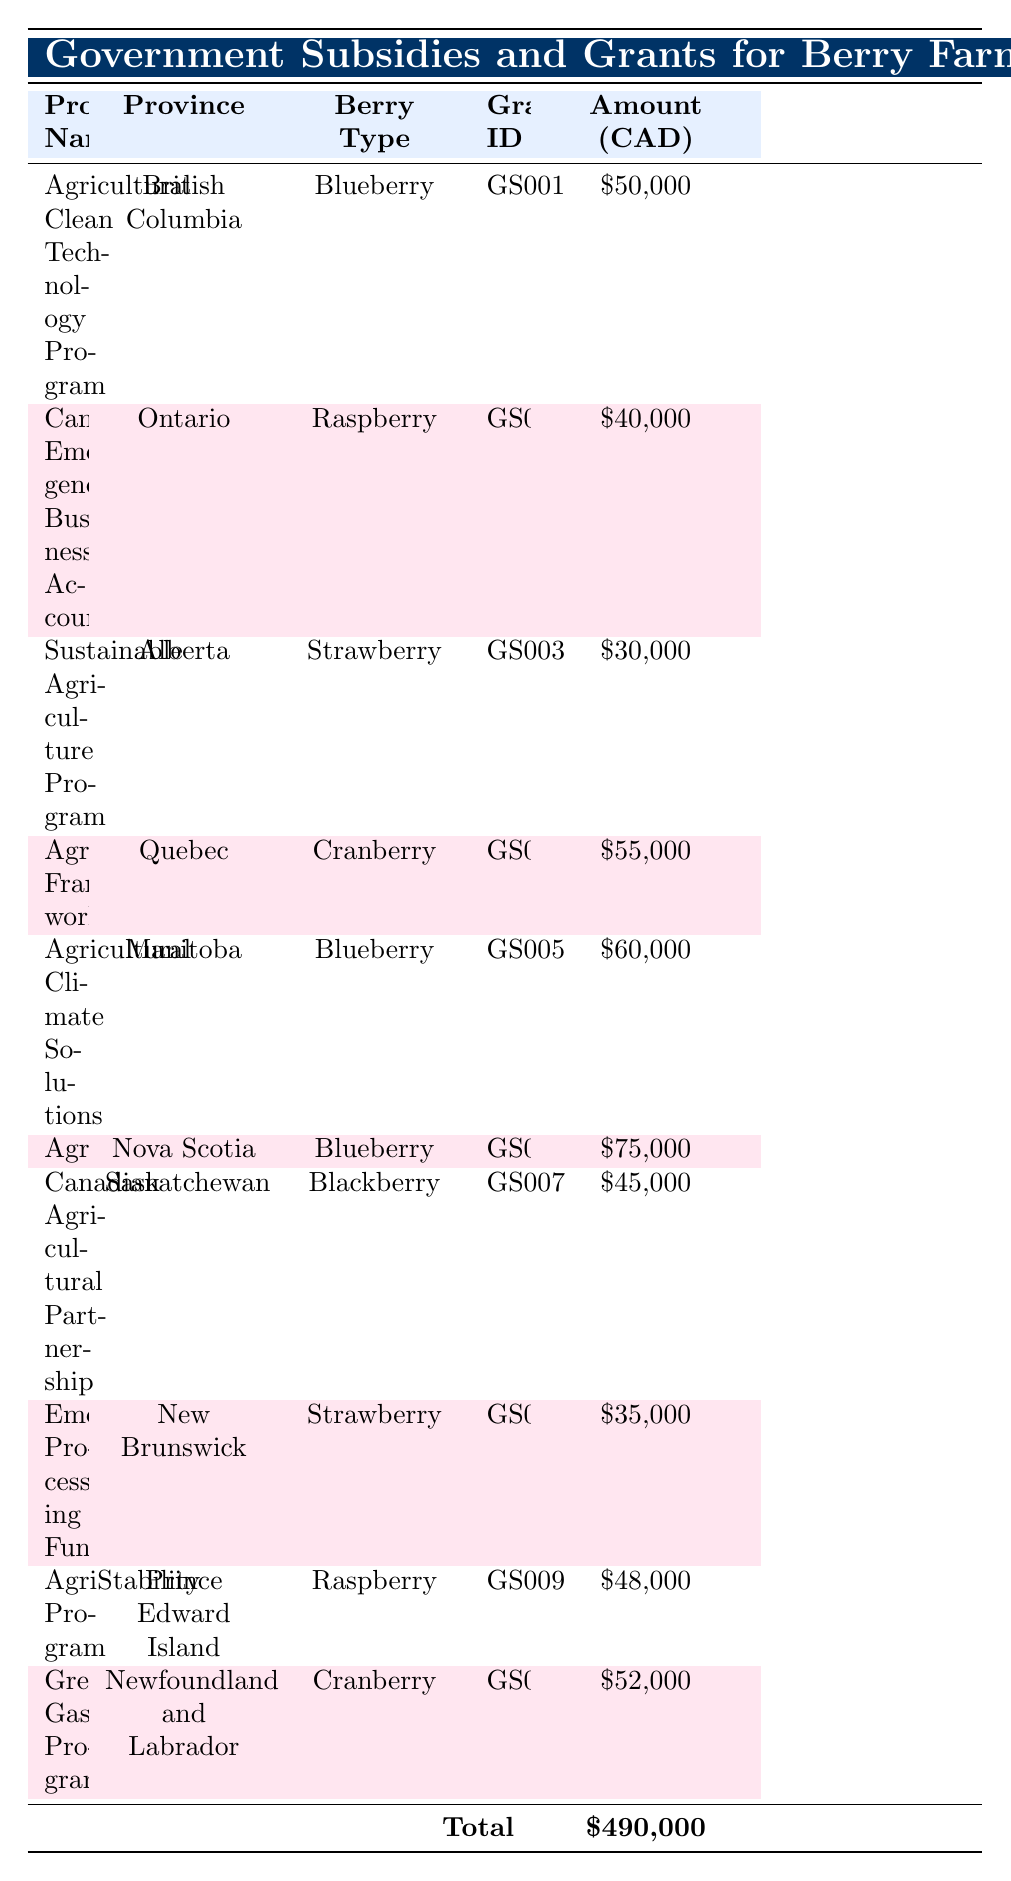What is the total amount of subsidies and grants received by berry farmers in Canada in 2021? The table shows that the total amount of subsidies and grants is listed at the bottom under the "Total" row, which indicates it sums up to 490,000 CAD.
Answer: 490,000 CAD Which berry type received the highest funding in 2021? By examining the "Amount (CAD)" column, we identify the maximum amount received. The "AgriInvest" grant for "Blueberry" in Nova Scotia received 75,000 CAD, which is the highest among all entries.
Answer: Blueberry Did farmers in Newfoundland and Labrador receive more funds than those in New Brunswick? We compare the "Amount (CAD)" for the entries from Newfoundland and Labrador (52,000 CAD) and New Brunswick (35,000 CAD). Since 52,000 is greater than 35,000, the statement is true.
Answer: Yes What is the average amount received by farmers for Raspberry in 2021? Farmers received funds through two grants: the "Canada Emergency Business Account" in Ontario (40,000 CAD) and the "AgriStability Program" in Prince Edward Island (48,000 CAD). To find the average, we compute (40,000 + 48,000)/2 = 44,000 CAD.
Answer: 44,000 CAD How many different berry types received funding from government grants in 2021? From the table, we list the unique berry types: Blueberry, Raspberry, Strawberry, Cranberry, and Blackberry. This results in a total of five different types.
Answer: 5 Was the grant received by farmers in Quebec greater than the one received by farmers in Alberta? The table shows that Quebec received 55,000 CAD through the "AgriRecovery Framework," and Alberta received 30,000 CAD through the "Sustainable Agriculture Program." Since 55,000 is indeed greater than 30,000, the statement is true.
Answer: Yes What is the total amount received by Blueberry farmers in 2021? We find all entries for Blueberry: 50,000 CAD (British Columbia), 60,000 CAD (Manitoba), and 75,000 CAD (Nova Scotia). Summing these amounts gives 50,000 + 60,000 + 75,000 = 185,000 CAD.
Answer: 185,000 CAD Which province received the least funding, and what was the amount? The table indicates that the lowest amount listed is 30,000 CAD from Alberta through the Sustainable Agriculture Program. Thus, Alberta received the least funding.
Answer: Alberta, 30,000 CAD What berry type was funded through the "Emergency Processing Fund"? Referring to the entry for the "Emergency Processing Fund," we see it was allocated for "Strawberry" in New Brunswick.
Answer: Strawberry 